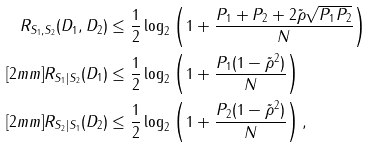Convert formula to latex. <formula><loc_0><loc_0><loc_500><loc_500>R _ { S _ { 1 } , S _ { 2 } } ( D _ { 1 } , D _ { 2 } ) & \leq \frac { 1 } { 2 } \log _ { 2 } \left ( 1 + \frac { P _ { 1 } + P _ { 2 } + 2 \tilde { \rho } \sqrt { P _ { 1 } P _ { 2 } } } { N } \right ) \\ [ 2 m m ] R _ { S _ { 1 } | S _ { 2 } } ( D _ { 1 } ) & \leq \frac { 1 } { 2 } \log _ { 2 } \left ( 1 + \frac { P _ { 1 } ( 1 - \tilde { \rho } ^ { 2 } ) } { N } \right ) \\ [ 2 m m ] R _ { S _ { 2 } | S _ { 1 } } ( D _ { 2 } ) & \leq \frac { 1 } { 2 } \log _ { 2 } \left ( 1 + \frac { P _ { 2 } ( 1 - \tilde { \rho } ^ { 2 } ) } { N } \right ) ,</formula> 